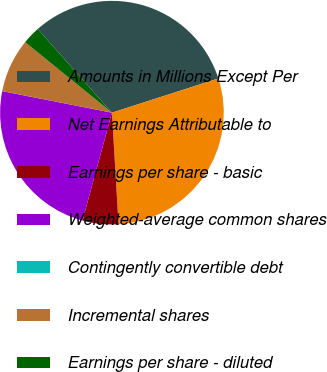Convert chart to OTSL. <chart><loc_0><loc_0><loc_500><loc_500><pie_chart><fcel>Amounts in Millions Except Per<fcel>Net Earnings Attributable to<fcel>Earnings per share - basic<fcel>Weighted-average common shares<fcel>Contingently convertible debt<fcel>Incremental shares<fcel>Earnings per share - diluted<nl><fcel>31.59%<fcel>29.01%<fcel>5.18%<fcel>23.85%<fcel>0.01%<fcel>7.76%<fcel>2.6%<nl></chart> 